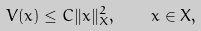<formula> <loc_0><loc_0><loc_500><loc_500>V ( x ) \leq C \| x \| _ { X } ^ { 2 } , \quad x \in X ,</formula> 